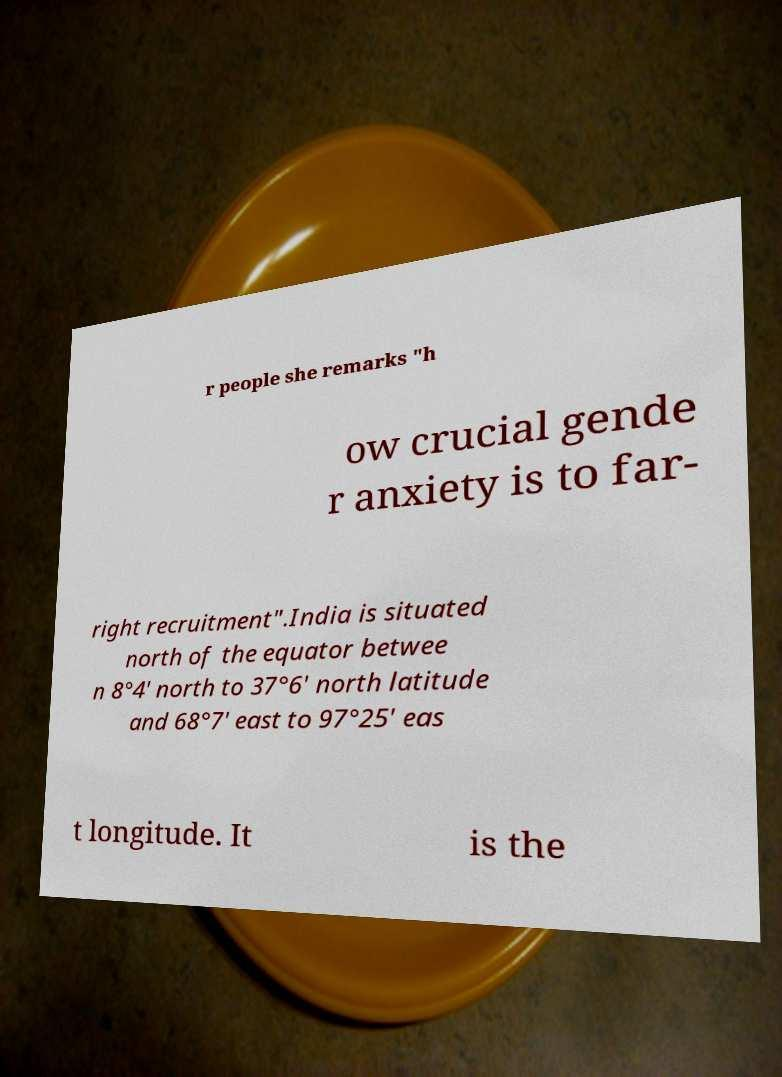What messages or text are displayed in this image? I need them in a readable, typed format. r people she remarks "h ow crucial gende r anxiety is to far- right recruitment".India is situated north of the equator betwee n 8°4' north to 37°6' north latitude and 68°7' east to 97°25' eas t longitude. It is the 